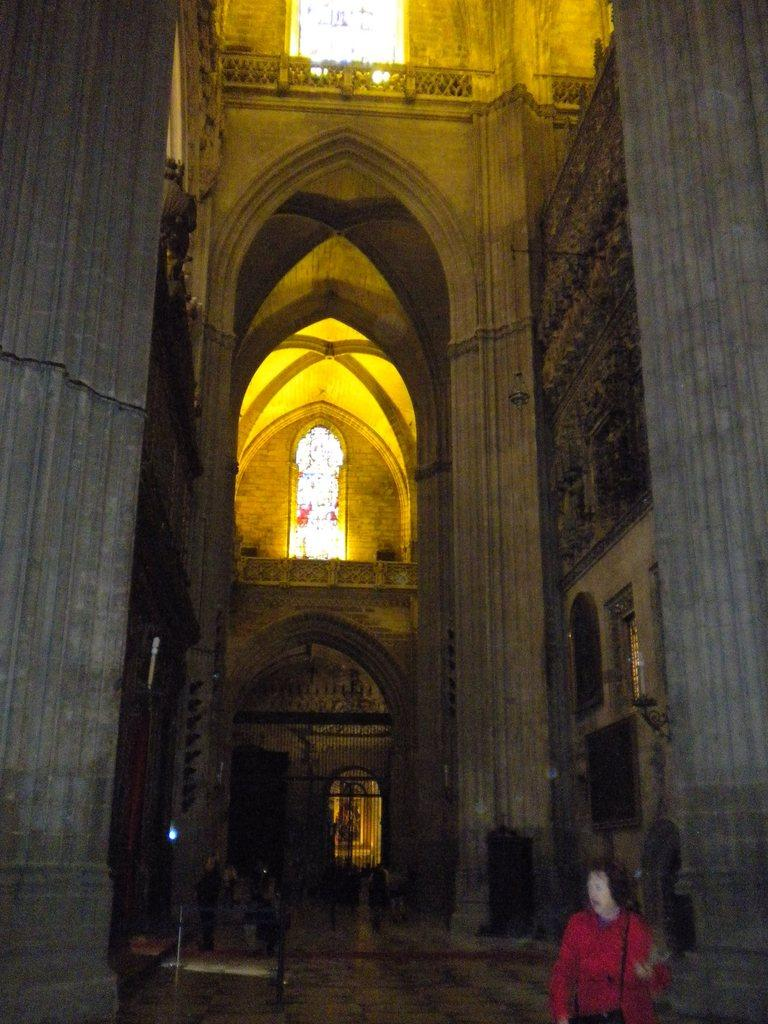What is the person in the image doing? The person is on the floor. What can be seen in the background of the image? There is a building in the image. Are there any openings in the building visible in the image? Yes, there are windows in the image. What else is present in the image besides the person and the building? There is a picture in the image. How does the person in the image use a quill to aid their digestion? There is no quill or reference to digestion in the image; the person is simply on the floor. 